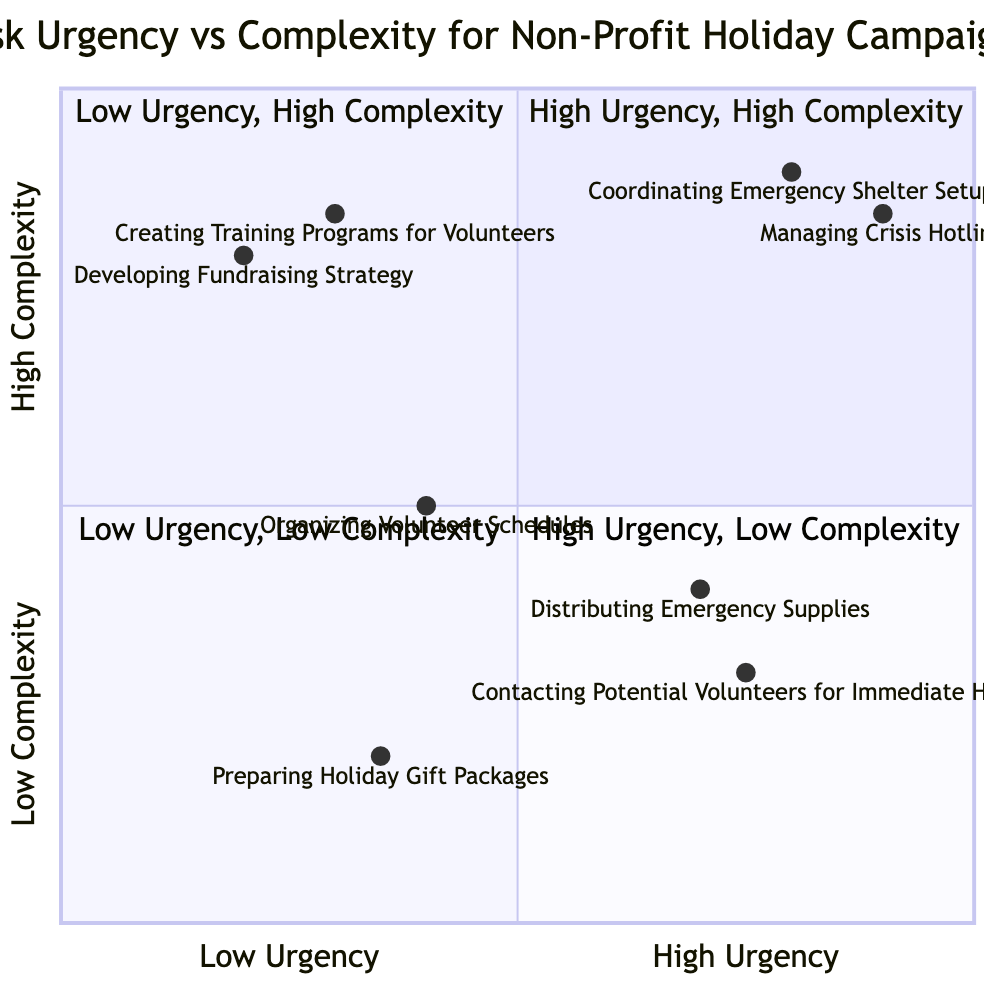What tasks require advanced skills in the high urgency and high complexity quadrant? In the "High Urgency - High Complexity" quadrant, the tasks listed are "Coordinating Emergency Shelter Setup" and "Managing Crisis Hotline." Both tasks are explicitly marked with the required skill level as "Advanced." Therefore, the answer is these two tasks.
Answer: Coordinating Emergency Shelter Setup, Managing Crisis Hotline How many tasks are in the low urgency and low complexity quadrant? The "Low Urgency - Low Complexity" quadrant contains two tasks: "Organizing Volunteer Schedules" and "Preparing Holiday Gift Packages." Counting these, we get a total of 2 tasks in this quadrant.
Answer: 2 Which task has the highest urgency and the lowest complexity? The "High Urgency - Low Complexity" quadrant contains the tasks "Distributing Emergency Supplies" and "Contacting Potential Volunteers for Immediate Help." Among these, both tasks are classified under "High Urgency" and "Low Complexity." Therefore, there is no distinction on which one has the highest urgency.
Answer: Distributing Emergency Supplies, Contacting Potential Volunteers for Immediate Help What skill level is required for developing a fundraising strategy? The task "Developing Fundraising Strategy" is located in the "Low Urgency - High Complexity" quadrant, and its required skill level is marked as "Advanced." Therefore, the answer to the required skill level for this task is "Advanced."
Answer: Advanced Which quadrant contains tasks that require an intermediate skill level? The "High Urgency - Low Complexity" quadrant includes the task "Distributing Emergency Supplies" which requires an "Intermediate" skill level. Similarly, the "Low Urgency - Low Complexity" quadrant also contains the task "Organizing Volunteer Schedules" with the same required skill level. Since both quadrants have tasks with intermediate skills, the answer encompasses both quadrants.
Answer: High Urgency - Low Complexity, Low Urgency - Low Complexity What is the relationship between urgency and complexity for the task "Creating Training Programs for Volunteers"? The task "Creating Training Programs for Volunteers" is located in the "Low Urgency - High Complexity" quadrant. This means that it is considered low urgency but high complexity, indicating a significant planning or execution effort required while not being time-sensitive.
Answer: Low Urgency - High Complexity 